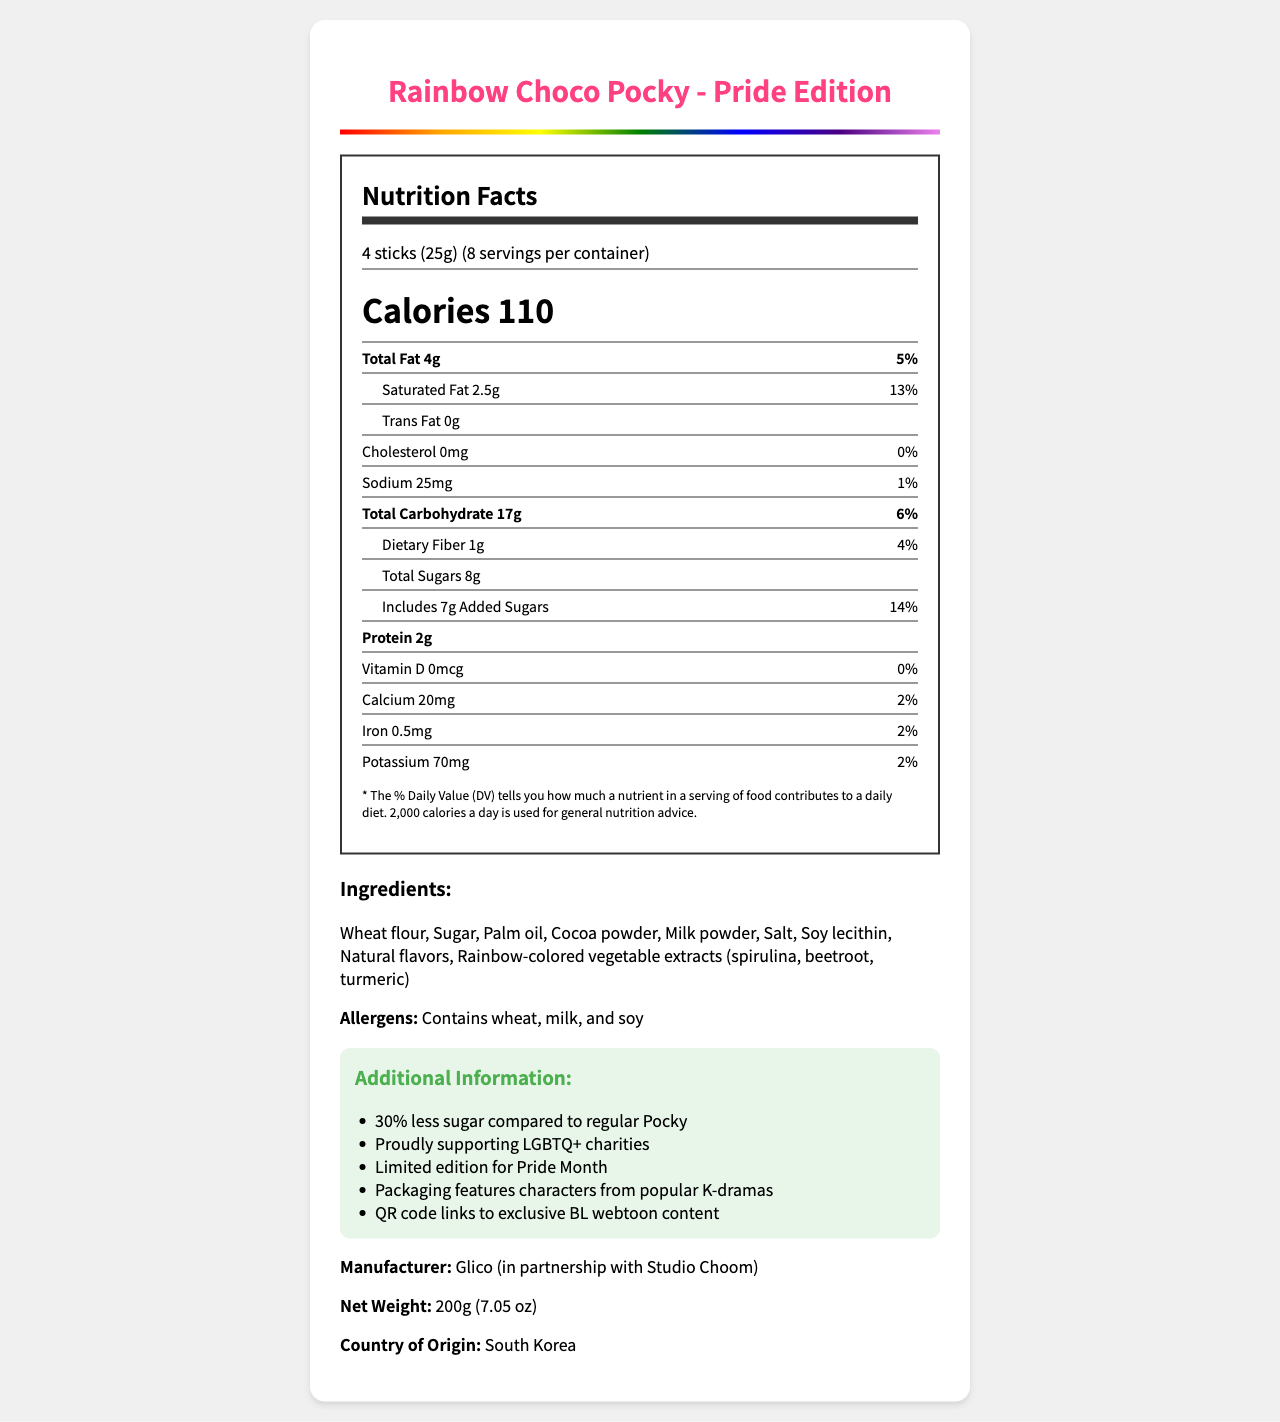what is the serving size? The serving size is explicitly mentioned as "4 sticks (25g)" in the document.
Answer: 4 sticks (25g) how many calories are in one serving? The document lists "Calories 110" as the calorie count per serving.
Answer: 110 calories what is the total fat content per serving? The document states that the total fat content per serving is "4g".
Answer: 4g how much sugar is in each serving? The document mentions "Total Sugars 8g" under the nutrient section.
Answer: 8g what ingredients are used in the Rainbow Choco Pocky – Pride Edition? The ingredients are clearly listed in the document.
Answer: Wheat flour, Sugar, Palm oil, Cocoa powder, Milk powder, Salt, Soy lecithin, Natural flavors, Rainbow-colored vegetable extracts (spirulina, beetroot, turmeric) how much protein does one serving contain? The document details the protein content per serving as "2g".
Answer: 2g what is the daily value percentage for calcium in one serving? The daily value for calcium is provided as "2%" in the nutrient section.
Answer: 2% what is the amount of sodium per serving? A. 10mg B. 25mg C. 50mg D. 75mg The document lists the amount of sodium per serving as "25mg".
Answer: B. 25mg which of the following allergens are present in this product? I. Wheat II. Milk III. Soy IV. Nuts The document clearly states "Contains wheat, milk, and soy".
Answer: I, II, III does the product contain any cholesterol? The cholesterol amount is listed as "0mg," indicating there is no cholesterol in the product.
Answer: No describe the purpose of this document. This summary encompasses the various sections of the document, including nutrient details, ingredients, additional information, and the product specifics.
Answer: The document provides nutritional information for the Rainbow Choco Pocky - Pride Edition, listing serving size, calories, nutrient amounts, ingredients, allergens, and additional information about the special edition and its support for LGBTQ+ charities. how does the sugar content in this Pride Edition compare to regular Pocky? The document states that the Pride Edition has "30% less sugar compared to regular Pocky".
Answer: 30% less sugar how many servings are there per container? The document specifies there are "8 servings per container".
Answer: 8 servings what unique features does the packaging include? The additional information section mentions these packaging features.
Answer: Characters from popular K-dramas and a QR code linking to exclusive BL webtoon content who is the manufacturer of this product? The document lists "Glico (in partnership with Studio Choom)" as the manufacturer.
Answer: Glico (in partnership with Studio Choom) what is the total weight of the product? The net weight is provided as "200g (7.05 oz)".
Answer: 200g (7.05 oz) what is the daily value percentage for iron? The daily value for iron is listed as "2%".
Answer: 2% what are the rainbow-colored vegetable extracts used in the ingredients? A. Asparagus and Carrot B. Spirulina and Beetroot C. Spinach and Blueberry The document lists "spirulina, beetroot, turmeric" as the rainbow-colored vegetable extracts.
Answer: B. Spirulina and Beetroot when is the Pride Edition available? The additional information section states that it is a "Limited edition for Pride Month".
Answer: Limited edition for Pride Month does the document specify the shelf life of the product? There is no information provided in the document regarding the shelf life of the product.
Answer: Cannot be determined 